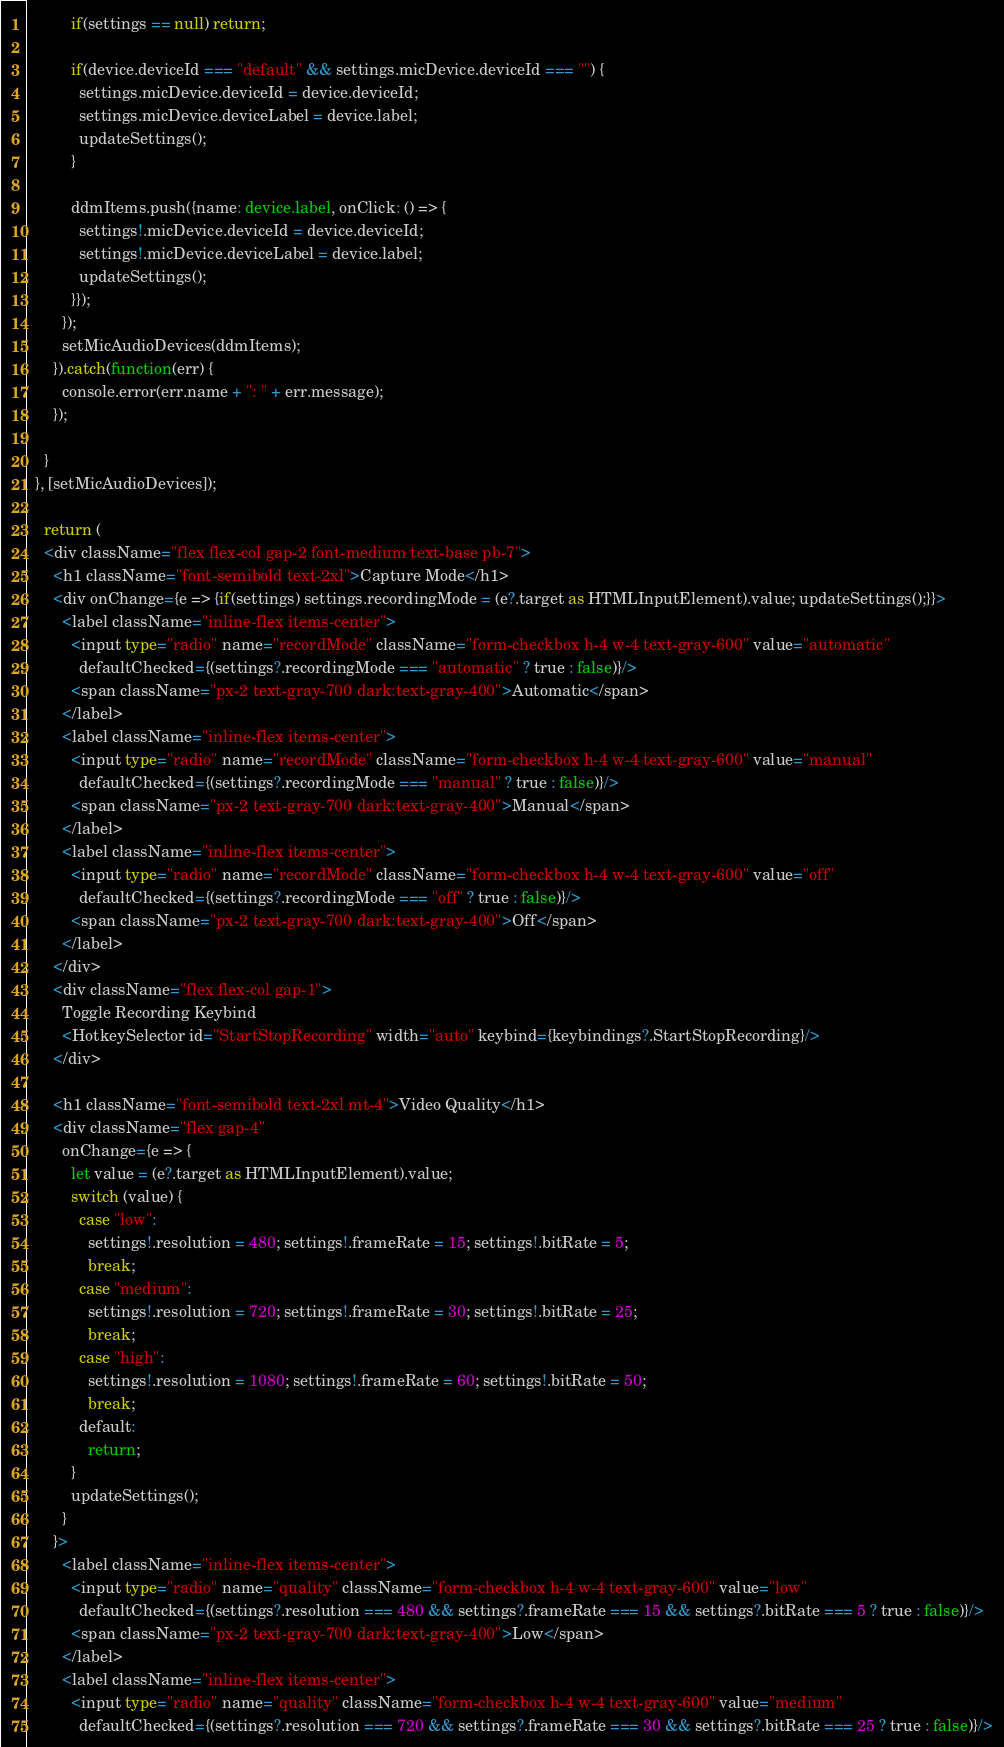Convert code to text. <code><loc_0><loc_0><loc_500><loc_500><_TypeScript_>          if(settings == null) return;

          if(device.deviceId === "default" && settings.micDevice.deviceId === "") {
            settings.micDevice.deviceId = device.deviceId; 
            settings.micDevice.deviceLabel = device.label;
            updateSettings();
          }

          ddmItems.push({name: device.label, onClick: () => {
            settings!.micDevice.deviceId = device.deviceId; 
            settings!.micDevice.deviceLabel = device.label; 
            updateSettings();
          }});
        });
        setMicAudioDevices(ddmItems);
      }).catch(function(err) {
        console.error(err.name + ": " + err.message);
      });

    }
  }, [setMicAudioDevices]);

	return (
    <div className="flex flex-col gap-2 font-medium text-base pb-7"> 
      <h1 className="font-semibold text-2xl">Capture Mode</h1>
      <div onChange={e => {if(settings) settings.recordingMode = (e?.target as HTMLInputElement).value; updateSettings();}}>
        <label className="inline-flex items-center">
          <input type="radio" name="recordMode" className="form-checkbox h-4 w-4 text-gray-600" value="automatic"
            defaultChecked={(settings?.recordingMode === "automatic" ? true : false)}/>
          <span className="px-2 text-gray-700 dark:text-gray-400">Automatic</span>
        </label>
        <label className="inline-flex items-center">
          <input type="radio" name="recordMode" className="form-checkbox h-4 w-4 text-gray-600" value="manual"
            defaultChecked={(settings?.recordingMode === "manual" ? true : false)}/>
          <span className="px-2 text-gray-700 dark:text-gray-400">Manual</span>
        </label>
        <label className="inline-flex items-center">
          <input type="radio" name="recordMode" className="form-checkbox h-4 w-4 text-gray-600" value="off"
            defaultChecked={(settings?.recordingMode === "off" ? true : false)}/>
          <span className="px-2 text-gray-700 dark:text-gray-400">Off</span>
        </label>
      </div>
      <div className="flex flex-col gap-1">
        Toggle Recording Keybind
        <HotkeySelector id="StartStopRecording" width="auto" keybind={keybindings?.StartStopRecording}/> 
      </div>

      <h1 className="font-semibold text-2xl mt-4">Video Quality</h1>
      <div className="flex gap-4" 
        onChange={e => {
          let value = (e?.target as HTMLInputElement).value;
          switch (value) {
            case "low":
              settings!.resolution = 480; settings!.frameRate = 15; settings!.bitRate = 5;
              break;
            case "medium":
              settings!.resolution = 720; settings!.frameRate = 30; settings!.bitRate = 25;
              break;
            case "high":
              settings!.resolution = 1080; settings!.frameRate = 60; settings!.bitRate = 50;
              break;
            default:
              return;
          }
          updateSettings();
        }
      }>
        <label className="inline-flex items-center">
          <input type="radio" name="quality" className="form-checkbox h-4 w-4 text-gray-600" value="low"
            defaultChecked={(settings?.resolution === 480 && settings?.frameRate === 15 && settings?.bitRate === 5 ? true : false)}/>
          <span className="px-2 text-gray-700 dark:text-gray-400">Low</span>
        </label>
        <label className="inline-flex items-center">
          <input type="radio" name="quality" className="form-checkbox h-4 w-4 text-gray-600" value="medium"
            defaultChecked={(settings?.resolution === 720 && settings?.frameRate === 30 && settings?.bitRate === 25 ? true : false)}/></code> 